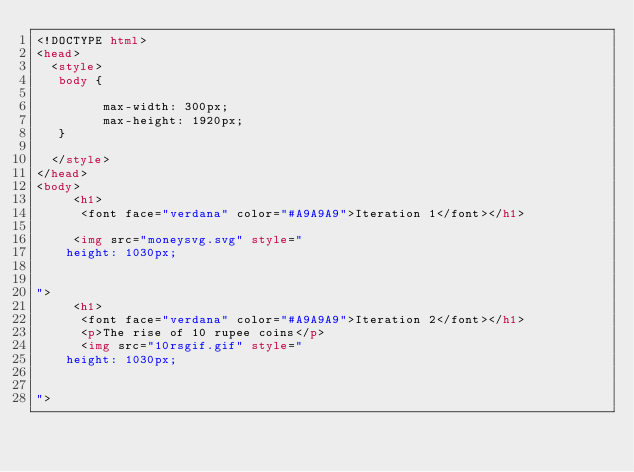Convert code to text. <code><loc_0><loc_0><loc_500><loc_500><_HTML_><!DOCTYPE html>
<head>
  <style>
   body {
         
         max-width: 300px;
         max-height: 1920px;
   } 

  </style>
</head>
<body>
     <h1>
      <font face="verdana" color="#A9A9A9">Iteration 1</font></h1>
   
     <img src="moneysvg.svg" style="
    height: 1030px;

    
">
     <h1>
      <font face="verdana" color="#A9A9A9">Iteration 2</font></h1>
      <p>The rise of 10 rupee coins</p>    
      <img src="10rsgif.gif" style="
    height: 1030px;

    
"> 


     </code> 